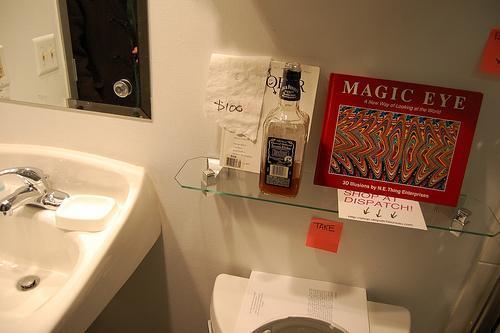How many pieces of soap are on the sink?
Give a very brief answer. 1. 